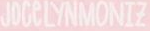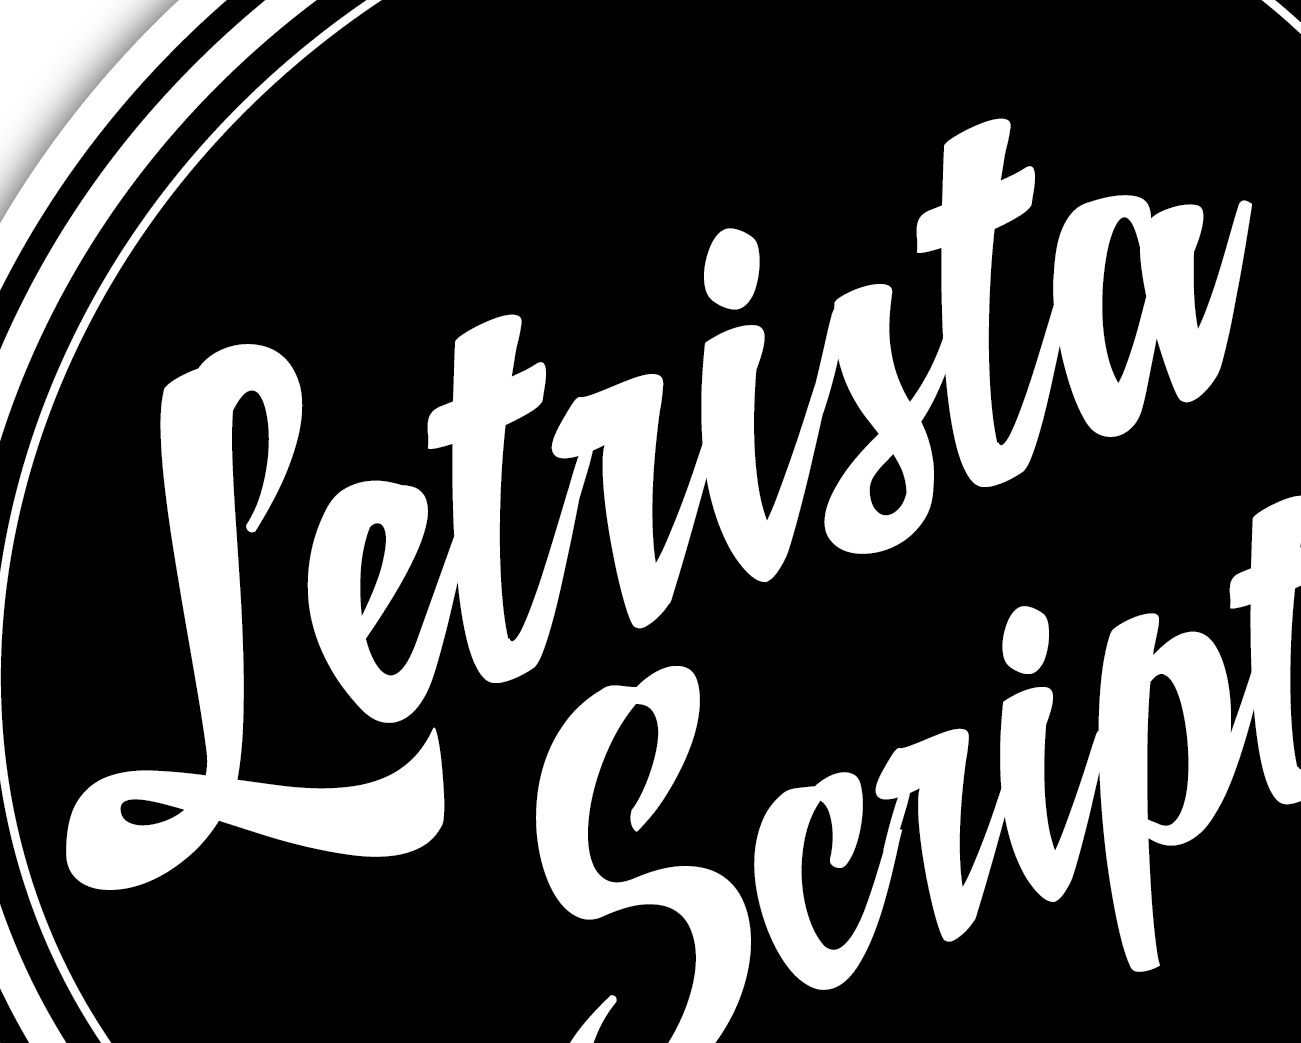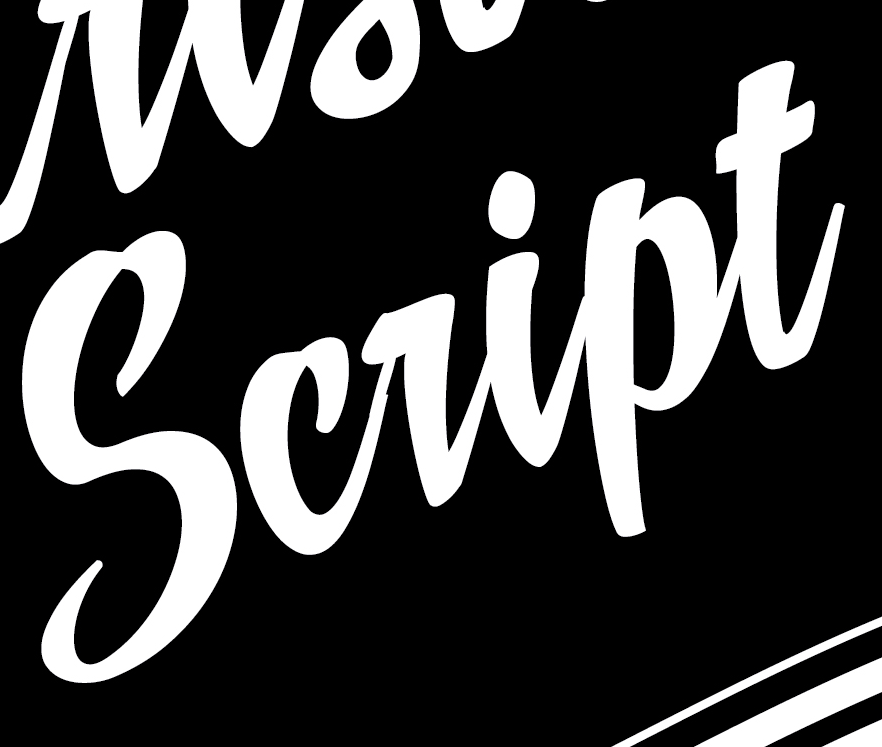What text appears in these images from left to right, separated by a semicolon? JOCeLYNMONIZ; Letrista; script 